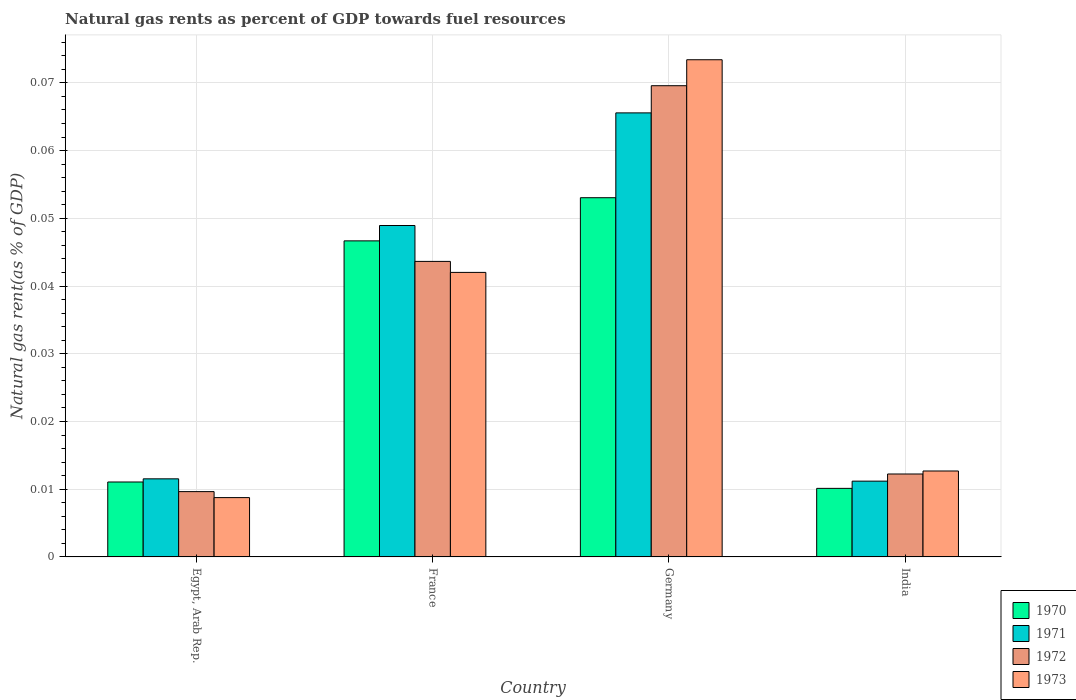Are the number of bars on each tick of the X-axis equal?
Ensure brevity in your answer.  Yes. How many bars are there on the 4th tick from the right?
Provide a succinct answer. 4. In how many cases, is the number of bars for a given country not equal to the number of legend labels?
Ensure brevity in your answer.  0. What is the natural gas rent in 1970 in India?
Make the answer very short. 0.01. Across all countries, what is the maximum natural gas rent in 1972?
Your answer should be very brief. 0.07. Across all countries, what is the minimum natural gas rent in 1971?
Offer a terse response. 0.01. What is the total natural gas rent in 1973 in the graph?
Offer a terse response. 0.14. What is the difference between the natural gas rent in 1971 in Egypt, Arab Rep. and that in France?
Your response must be concise. -0.04. What is the difference between the natural gas rent in 1973 in France and the natural gas rent in 1972 in India?
Keep it short and to the point. 0.03. What is the average natural gas rent in 1971 per country?
Offer a terse response. 0.03. What is the difference between the natural gas rent of/in 1972 and natural gas rent of/in 1973 in France?
Ensure brevity in your answer.  0. In how many countries, is the natural gas rent in 1972 greater than 0.07400000000000001 %?
Your answer should be very brief. 0. What is the ratio of the natural gas rent in 1971 in France to that in India?
Offer a very short reply. 4.37. What is the difference between the highest and the second highest natural gas rent in 1971?
Keep it short and to the point. 0.02. What is the difference between the highest and the lowest natural gas rent in 1970?
Ensure brevity in your answer.  0.04. In how many countries, is the natural gas rent in 1970 greater than the average natural gas rent in 1970 taken over all countries?
Make the answer very short. 2. What does the 4th bar from the left in Egypt, Arab Rep. represents?
Give a very brief answer. 1973. How many bars are there?
Provide a succinct answer. 16. Are the values on the major ticks of Y-axis written in scientific E-notation?
Offer a very short reply. No. Does the graph contain any zero values?
Offer a very short reply. No. What is the title of the graph?
Offer a very short reply. Natural gas rents as percent of GDP towards fuel resources. Does "2006" appear as one of the legend labels in the graph?
Your answer should be compact. No. What is the label or title of the X-axis?
Provide a short and direct response. Country. What is the label or title of the Y-axis?
Give a very brief answer. Natural gas rent(as % of GDP). What is the Natural gas rent(as % of GDP) in 1970 in Egypt, Arab Rep.?
Provide a short and direct response. 0.01. What is the Natural gas rent(as % of GDP) in 1971 in Egypt, Arab Rep.?
Provide a short and direct response. 0.01. What is the Natural gas rent(as % of GDP) in 1972 in Egypt, Arab Rep.?
Provide a short and direct response. 0.01. What is the Natural gas rent(as % of GDP) in 1973 in Egypt, Arab Rep.?
Ensure brevity in your answer.  0.01. What is the Natural gas rent(as % of GDP) in 1970 in France?
Your answer should be compact. 0.05. What is the Natural gas rent(as % of GDP) in 1971 in France?
Your response must be concise. 0.05. What is the Natural gas rent(as % of GDP) of 1972 in France?
Your answer should be compact. 0.04. What is the Natural gas rent(as % of GDP) in 1973 in France?
Ensure brevity in your answer.  0.04. What is the Natural gas rent(as % of GDP) in 1970 in Germany?
Offer a terse response. 0.05. What is the Natural gas rent(as % of GDP) in 1971 in Germany?
Offer a very short reply. 0.07. What is the Natural gas rent(as % of GDP) in 1972 in Germany?
Your answer should be very brief. 0.07. What is the Natural gas rent(as % of GDP) in 1973 in Germany?
Provide a succinct answer. 0.07. What is the Natural gas rent(as % of GDP) in 1970 in India?
Keep it short and to the point. 0.01. What is the Natural gas rent(as % of GDP) in 1971 in India?
Your response must be concise. 0.01. What is the Natural gas rent(as % of GDP) of 1972 in India?
Offer a very short reply. 0.01. What is the Natural gas rent(as % of GDP) in 1973 in India?
Provide a short and direct response. 0.01. Across all countries, what is the maximum Natural gas rent(as % of GDP) of 1970?
Give a very brief answer. 0.05. Across all countries, what is the maximum Natural gas rent(as % of GDP) of 1971?
Offer a very short reply. 0.07. Across all countries, what is the maximum Natural gas rent(as % of GDP) in 1972?
Provide a short and direct response. 0.07. Across all countries, what is the maximum Natural gas rent(as % of GDP) in 1973?
Provide a succinct answer. 0.07. Across all countries, what is the minimum Natural gas rent(as % of GDP) in 1970?
Your response must be concise. 0.01. Across all countries, what is the minimum Natural gas rent(as % of GDP) in 1971?
Provide a succinct answer. 0.01. Across all countries, what is the minimum Natural gas rent(as % of GDP) of 1972?
Offer a terse response. 0.01. Across all countries, what is the minimum Natural gas rent(as % of GDP) in 1973?
Ensure brevity in your answer.  0.01. What is the total Natural gas rent(as % of GDP) of 1970 in the graph?
Ensure brevity in your answer.  0.12. What is the total Natural gas rent(as % of GDP) of 1971 in the graph?
Offer a very short reply. 0.14. What is the total Natural gas rent(as % of GDP) in 1972 in the graph?
Provide a succinct answer. 0.14. What is the total Natural gas rent(as % of GDP) in 1973 in the graph?
Offer a very short reply. 0.14. What is the difference between the Natural gas rent(as % of GDP) in 1970 in Egypt, Arab Rep. and that in France?
Offer a very short reply. -0.04. What is the difference between the Natural gas rent(as % of GDP) in 1971 in Egypt, Arab Rep. and that in France?
Provide a succinct answer. -0.04. What is the difference between the Natural gas rent(as % of GDP) of 1972 in Egypt, Arab Rep. and that in France?
Keep it short and to the point. -0.03. What is the difference between the Natural gas rent(as % of GDP) of 1973 in Egypt, Arab Rep. and that in France?
Provide a short and direct response. -0.03. What is the difference between the Natural gas rent(as % of GDP) in 1970 in Egypt, Arab Rep. and that in Germany?
Offer a very short reply. -0.04. What is the difference between the Natural gas rent(as % of GDP) in 1971 in Egypt, Arab Rep. and that in Germany?
Offer a very short reply. -0.05. What is the difference between the Natural gas rent(as % of GDP) in 1972 in Egypt, Arab Rep. and that in Germany?
Your response must be concise. -0.06. What is the difference between the Natural gas rent(as % of GDP) in 1973 in Egypt, Arab Rep. and that in Germany?
Provide a short and direct response. -0.06. What is the difference between the Natural gas rent(as % of GDP) of 1970 in Egypt, Arab Rep. and that in India?
Offer a terse response. 0. What is the difference between the Natural gas rent(as % of GDP) of 1971 in Egypt, Arab Rep. and that in India?
Your answer should be compact. 0. What is the difference between the Natural gas rent(as % of GDP) of 1972 in Egypt, Arab Rep. and that in India?
Offer a very short reply. -0. What is the difference between the Natural gas rent(as % of GDP) in 1973 in Egypt, Arab Rep. and that in India?
Make the answer very short. -0. What is the difference between the Natural gas rent(as % of GDP) of 1970 in France and that in Germany?
Ensure brevity in your answer.  -0.01. What is the difference between the Natural gas rent(as % of GDP) in 1971 in France and that in Germany?
Your answer should be very brief. -0.02. What is the difference between the Natural gas rent(as % of GDP) of 1972 in France and that in Germany?
Provide a succinct answer. -0.03. What is the difference between the Natural gas rent(as % of GDP) of 1973 in France and that in Germany?
Give a very brief answer. -0.03. What is the difference between the Natural gas rent(as % of GDP) in 1970 in France and that in India?
Your answer should be compact. 0.04. What is the difference between the Natural gas rent(as % of GDP) of 1971 in France and that in India?
Your response must be concise. 0.04. What is the difference between the Natural gas rent(as % of GDP) of 1972 in France and that in India?
Your response must be concise. 0.03. What is the difference between the Natural gas rent(as % of GDP) of 1973 in France and that in India?
Keep it short and to the point. 0.03. What is the difference between the Natural gas rent(as % of GDP) of 1970 in Germany and that in India?
Keep it short and to the point. 0.04. What is the difference between the Natural gas rent(as % of GDP) of 1971 in Germany and that in India?
Make the answer very short. 0.05. What is the difference between the Natural gas rent(as % of GDP) in 1972 in Germany and that in India?
Your response must be concise. 0.06. What is the difference between the Natural gas rent(as % of GDP) in 1973 in Germany and that in India?
Provide a short and direct response. 0.06. What is the difference between the Natural gas rent(as % of GDP) in 1970 in Egypt, Arab Rep. and the Natural gas rent(as % of GDP) in 1971 in France?
Your answer should be very brief. -0.04. What is the difference between the Natural gas rent(as % of GDP) in 1970 in Egypt, Arab Rep. and the Natural gas rent(as % of GDP) in 1972 in France?
Keep it short and to the point. -0.03. What is the difference between the Natural gas rent(as % of GDP) in 1970 in Egypt, Arab Rep. and the Natural gas rent(as % of GDP) in 1973 in France?
Offer a terse response. -0.03. What is the difference between the Natural gas rent(as % of GDP) of 1971 in Egypt, Arab Rep. and the Natural gas rent(as % of GDP) of 1972 in France?
Your answer should be very brief. -0.03. What is the difference between the Natural gas rent(as % of GDP) of 1971 in Egypt, Arab Rep. and the Natural gas rent(as % of GDP) of 1973 in France?
Make the answer very short. -0.03. What is the difference between the Natural gas rent(as % of GDP) of 1972 in Egypt, Arab Rep. and the Natural gas rent(as % of GDP) of 1973 in France?
Offer a terse response. -0.03. What is the difference between the Natural gas rent(as % of GDP) of 1970 in Egypt, Arab Rep. and the Natural gas rent(as % of GDP) of 1971 in Germany?
Offer a very short reply. -0.05. What is the difference between the Natural gas rent(as % of GDP) of 1970 in Egypt, Arab Rep. and the Natural gas rent(as % of GDP) of 1972 in Germany?
Keep it short and to the point. -0.06. What is the difference between the Natural gas rent(as % of GDP) in 1970 in Egypt, Arab Rep. and the Natural gas rent(as % of GDP) in 1973 in Germany?
Offer a terse response. -0.06. What is the difference between the Natural gas rent(as % of GDP) in 1971 in Egypt, Arab Rep. and the Natural gas rent(as % of GDP) in 1972 in Germany?
Your answer should be compact. -0.06. What is the difference between the Natural gas rent(as % of GDP) in 1971 in Egypt, Arab Rep. and the Natural gas rent(as % of GDP) in 1973 in Germany?
Make the answer very short. -0.06. What is the difference between the Natural gas rent(as % of GDP) of 1972 in Egypt, Arab Rep. and the Natural gas rent(as % of GDP) of 1973 in Germany?
Your answer should be very brief. -0.06. What is the difference between the Natural gas rent(as % of GDP) in 1970 in Egypt, Arab Rep. and the Natural gas rent(as % of GDP) in 1971 in India?
Provide a short and direct response. -0. What is the difference between the Natural gas rent(as % of GDP) of 1970 in Egypt, Arab Rep. and the Natural gas rent(as % of GDP) of 1972 in India?
Offer a very short reply. -0. What is the difference between the Natural gas rent(as % of GDP) in 1970 in Egypt, Arab Rep. and the Natural gas rent(as % of GDP) in 1973 in India?
Give a very brief answer. -0. What is the difference between the Natural gas rent(as % of GDP) of 1971 in Egypt, Arab Rep. and the Natural gas rent(as % of GDP) of 1972 in India?
Your response must be concise. -0. What is the difference between the Natural gas rent(as % of GDP) of 1971 in Egypt, Arab Rep. and the Natural gas rent(as % of GDP) of 1973 in India?
Make the answer very short. -0. What is the difference between the Natural gas rent(as % of GDP) in 1972 in Egypt, Arab Rep. and the Natural gas rent(as % of GDP) in 1973 in India?
Offer a very short reply. -0. What is the difference between the Natural gas rent(as % of GDP) of 1970 in France and the Natural gas rent(as % of GDP) of 1971 in Germany?
Offer a terse response. -0.02. What is the difference between the Natural gas rent(as % of GDP) of 1970 in France and the Natural gas rent(as % of GDP) of 1972 in Germany?
Your response must be concise. -0.02. What is the difference between the Natural gas rent(as % of GDP) in 1970 in France and the Natural gas rent(as % of GDP) in 1973 in Germany?
Provide a short and direct response. -0.03. What is the difference between the Natural gas rent(as % of GDP) in 1971 in France and the Natural gas rent(as % of GDP) in 1972 in Germany?
Your answer should be very brief. -0.02. What is the difference between the Natural gas rent(as % of GDP) of 1971 in France and the Natural gas rent(as % of GDP) of 1973 in Germany?
Ensure brevity in your answer.  -0.02. What is the difference between the Natural gas rent(as % of GDP) in 1972 in France and the Natural gas rent(as % of GDP) in 1973 in Germany?
Provide a short and direct response. -0.03. What is the difference between the Natural gas rent(as % of GDP) of 1970 in France and the Natural gas rent(as % of GDP) of 1971 in India?
Offer a very short reply. 0.04. What is the difference between the Natural gas rent(as % of GDP) in 1970 in France and the Natural gas rent(as % of GDP) in 1972 in India?
Your response must be concise. 0.03. What is the difference between the Natural gas rent(as % of GDP) in 1970 in France and the Natural gas rent(as % of GDP) in 1973 in India?
Make the answer very short. 0.03. What is the difference between the Natural gas rent(as % of GDP) of 1971 in France and the Natural gas rent(as % of GDP) of 1972 in India?
Your answer should be very brief. 0.04. What is the difference between the Natural gas rent(as % of GDP) in 1971 in France and the Natural gas rent(as % of GDP) in 1973 in India?
Ensure brevity in your answer.  0.04. What is the difference between the Natural gas rent(as % of GDP) in 1972 in France and the Natural gas rent(as % of GDP) in 1973 in India?
Make the answer very short. 0.03. What is the difference between the Natural gas rent(as % of GDP) in 1970 in Germany and the Natural gas rent(as % of GDP) in 1971 in India?
Your answer should be very brief. 0.04. What is the difference between the Natural gas rent(as % of GDP) of 1970 in Germany and the Natural gas rent(as % of GDP) of 1972 in India?
Your response must be concise. 0.04. What is the difference between the Natural gas rent(as % of GDP) of 1970 in Germany and the Natural gas rent(as % of GDP) of 1973 in India?
Give a very brief answer. 0.04. What is the difference between the Natural gas rent(as % of GDP) of 1971 in Germany and the Natural gas rent(as % of GDP) of 1972 in India?
Keep it short and to the point. 0.05. What is the difference between the Natural gas rent(as % of GDP) in 1971 in Germany and the Natural gas rent(as % of GDP) in 1973 in India?
Offer a very short reply. 0.05. What is the difference between the Natural gas rent(as % of GDP) in 1972 in Germany and the Natural gas rent(as % of GDP) in 1973 in India?
Your response must be concise. 0.06. What is the average Natural gas rent(as % of GDP) of 1970 per country?
Your answer should be compact. 0.03. What is the average Natural gas rent(as % of GDP) of 1971 per country?
Your response must be concise. 0.03. What is the average Natural gas rent(as % of GDP) in 1972 per country?
Offer a very short reply. 0.03. What is the average Natural gas rent(as % of GDP) in 1973 per country?
Ensure brevity in your answer.  0.03. What is the difference between the Natural gas rent(as % of GDP) in 1970 and Natural gas rent(as % of GDP) in 1971 in Egypt, Arab Rep.?
Your answer should be very brief. -0. What is the difference between the Natural gas rent(as % of GDP) of 1970 and Natural gas rent(as % of GDP) of 1972 in Egypt, Arab Rep.?
Provide a short and direct response. 0. What is the difference between the Natural gas rent(as % of GDP) of 1970 and Natural gas rent(as % of GDP) of 1973 in Egypt, Arab Rep.?
Offer a very short reply. 0. What is the difference between the Natural gas rent(as % of GDP) in 1971 and Natural gas rent(as % of GDP) in 1972 in Egypt, Arab Rep.?
Provide a succinct answer. 0. What is the difference between the Natural gas rent(as % of GDP) in 1971 and Natural gas rent(as % of GDP) in 1973 in Egypt, Arab Rep.?
Ensure brevity in your answer.  0. What is the difference between the Natural gas rent(as % of GDP) in 1972 and Natural gas rent(as % of GDP) in 1973 in Egypt, Arab Rep.?
Give a very brief answer. 0. What is the difference between the Natural gas rent(as % of GDP) in 1970 and Natural gas rent(as % of GDP) in 1971 in France?
Ensure brevity in your answer.  -0. What is the difference between the Natural gas rent(as % of GDP) of 1970 and Natural gas rent(as % of GDP) of 1972 in France?
Your response must be concise. 0. What is the difference between the Natural gas rent(as % of GDP) in 1970 and Natural gas rent(as % of GDP) in 1973 in France?
Offer a terse response. 0. What is the difference between the Natural gas rent(as % of GDP) in 1971 and Natural gas rent(as % of GDP) in 1972 in France?
Ensure brevity in your answer.  0.01. What is the difference between the Natural gas rent(as % of GDP) in 1971 and Natural gas rent(as % of GDP) in 1973 in France?
Offer a very short reply. 0.01. What is the difference between the Natural gas rent(as % of GDP) in 1972 and Natural gas rent(as % of GDP) in 1973 in France?
Offer a terse response. 0. What is the difference between the Natural gas rent(as % of GDP) of 1970 and Natural gas rent(as % of GDP) of 1971 in Germany?
Keep it short and to the point. -0.01. What is the difference between the Natural gas rent(as % of GDP) in 1970 and Natural gas rent(as % of GDP) in 1972 in Germany?
Keep it short and to the point. -0.02. What is the difference between the Natural gas rent(as % of GDP) in 1970 and Natural gas rent(as % of GDP) in 1973 in Germany?
Your answer should be compact. -0.02. What is the difference between the Natural gas rent(as % of GDP) of 1971 and Natural gas rent(as % of GDP) of 1972 in Germany?
Give a very brief answer. -0. What is the difference between the Natural gas rent(as % of GDP) of 1971 and Natural gas rent(as % of GDP) of 1973 in Germany?
Your answer should be very brief. -0.01. What is the difference between the Natural gas rent(as % of GDP) of 1972 and Natural gas rent(as % of GDP) of 1973 in Germany?
Provide a short and direct response. -0. What is the difference between the Natural gas rent(as % of GDP) in 1970 and Natural gas rent(as % of GDP) in 1971 in India?
Keep it short and to the point. -0. What is the difference between the Natural gas rent(as % of GDP) of 1970 and Natural gas rent(as % of GDP) of 1972 in India?
Offer a terse response. -0. What is the difference between the Natural gas rent(as % of GDP) in 1970 and Natural gas rent(as % of GDP) in 1973 in India?
Offer a terse response. -0. What is the difference between the Natural gas rent(as % of GDP) of 1971 and Natural gas rent(as % of GDP) of 1972 in India?
Provide a short and direct response. -0. What is the difference between the Natural gas rent(as % of GDP) in 1971 and Natural gas rent(as % of GDP) in 1973 in India?
Provide a short and direct response. -0. What is the difference between the Natural gas rent(as % of GDP) in 1972 and Natural gas rent(as % of GDP) in 1973 in India?
Provide a short and direct response. -0. What is the ratio of the Natural gas rent(as % of GDP) of 1970 in Egypt, Arab Rep. to that in France?
Ensure brevity in your answer.  0.24. What is the ratio of the Natural gas rent(as % of GDP) of 1971 in Egypt, Arab Rep. to that in France?
Offer a very short reply. 0.24. What is the ratio of the Natural gas rent(as % of GDP) in 1972 in Egypt, Arab Rep. to that in France?
Your answer should be very brief. 0.22. What is the ratio of the Natural gas rent(as % of GDP) of 1973 in Egypt, Arab Rep. to that in France?
Provide a short and direct response. 0.21. What is the ratio of the Natural gas rent(as % of GDP) of 1970 in Egypt, Arab Rep. to that in Germany?
Your answer should be very brief. 0.21. What is the ratio of the Natural gas rent(as % of GDP) in 1971 in Egypt, Arab Rep. to that in Germany?
Your answer should be compact. 0.18. What is the ratio of the Natural gas rent(as % of GDP) in 1972 in Egypt, Arab Rep. to that in Germany?
Give a very brief answer. 0.14. What is the ratio of the Natural gas rent(as % of GDP) of 1973 in Egypt, Arab Rep. to that in Germany?
Your answer should be very brief. 0.12. What is the ratio of the Natural gas rent(as % of GDP) of 1970 in Egypt, Arab Rep. to that in India?
Provide a short and direct response. 1.09. What is the ratio of the Natural gas rent(as % of GDP) in 1971 in Egypt, Arab Rep. to that in India?
Provide a succinct answer. 1.03. What is the ratio of the Natural gas rent(as % of GDP) of 1972 in Egypt, Arab Rep. to that in India?
Keep it short and to the point. 0.79. What is the ratio of the Natural gas rent(as % of GDP) of 1973 in Egypt, Arab Rep. to that in India?
Your answer should be very brief. 0.69. What is the ratio of the Natural gas rent(as % of GDP) of 1970 in France to that in Germany?
Your answer should be compact. 0.88. What is the ratio of the Natural gas rent(as % of GDP) in 1971 in France to that in Germany?
Provide a short and direct response. 0.75. What is the ratio of the Natural gas rent(as % of GDP) in 1972 in France to that in Germany?
Your response must be concise. 0.63. What is the ratio of the Natural gas rent(as % of GDP) of 1973 in France to that in Germany?
Provide a short and direct response. 0.57. What is the ratio of the Natural gas rent(as % of GDP) in 1970 in France to that in India?
Your response must be concise. 4.61. What is the ratio of the Natural gas rent(as % of GDP) of 1971 in France to that in India?
Provide a succinct answer. 4.37. What is the ratio of the Natural gas rent(as % of GDP) in 1972 in France to that in India?
Provide a succinct answer. 3.56. What is the ratio of the Natural gas rent(as % of GDP) in 1973 in France to that in India?
Your answer should be very brief. 3.31. What is the ratio of the Natural gas rent(as % of GDP) of 1970 in Germany to that in India?
Provide a short and direct response. 5.24. What is the ratio of the Natural gas rent(as % of GDP) of 1971 in Germany to that in India?
Ensure brevity in your answer.  5.86. What is the ratio of the Natural gas rent(as % of GDP) of 1972 in Germany to that in India?
Offer a very short reply. 5.68. What is the ratio of the Natural gas rent(as % of GDP) of 1973 in Germany to that in India?
Provide a succinct answer. 5.79. What is the difference between the highest and the second highest Natural gas rent(as % of GDP) in 1970?
Keep it short and to the point. 0.01. What is the difference between the highest and the second highest Natural gas rent(as % of GDP) of 1971?
Give a very brief answer. 0.02. What is the difference between the highest and the second highest Natural gas rent(as % of GDP) of 1972?
Offer a very short reply. 0.03. What is the difference between the highest and the second highest Natural gas rent(as % of GDP) of 1973?
Provide a short and direct response. 0.03. What is the difference between the highest and the lowest Natural gas rent(as % of GDP) of 1970?
Keep it short and to the point. 0.04. What is the difference between the highest and the lowest Natural gas rent(as % of GDP) of 1971?
Offer a very short reply. 0.05. What is the difference between the highest and the lowest Natural gas rent(as % of GDP) in 1972?
Provide a succinct answer. 0.06. What is the difference between the highest and the lowest Natural gas rent(as % of GDP) of 1973?
Your answer should be compact. 0.06. 